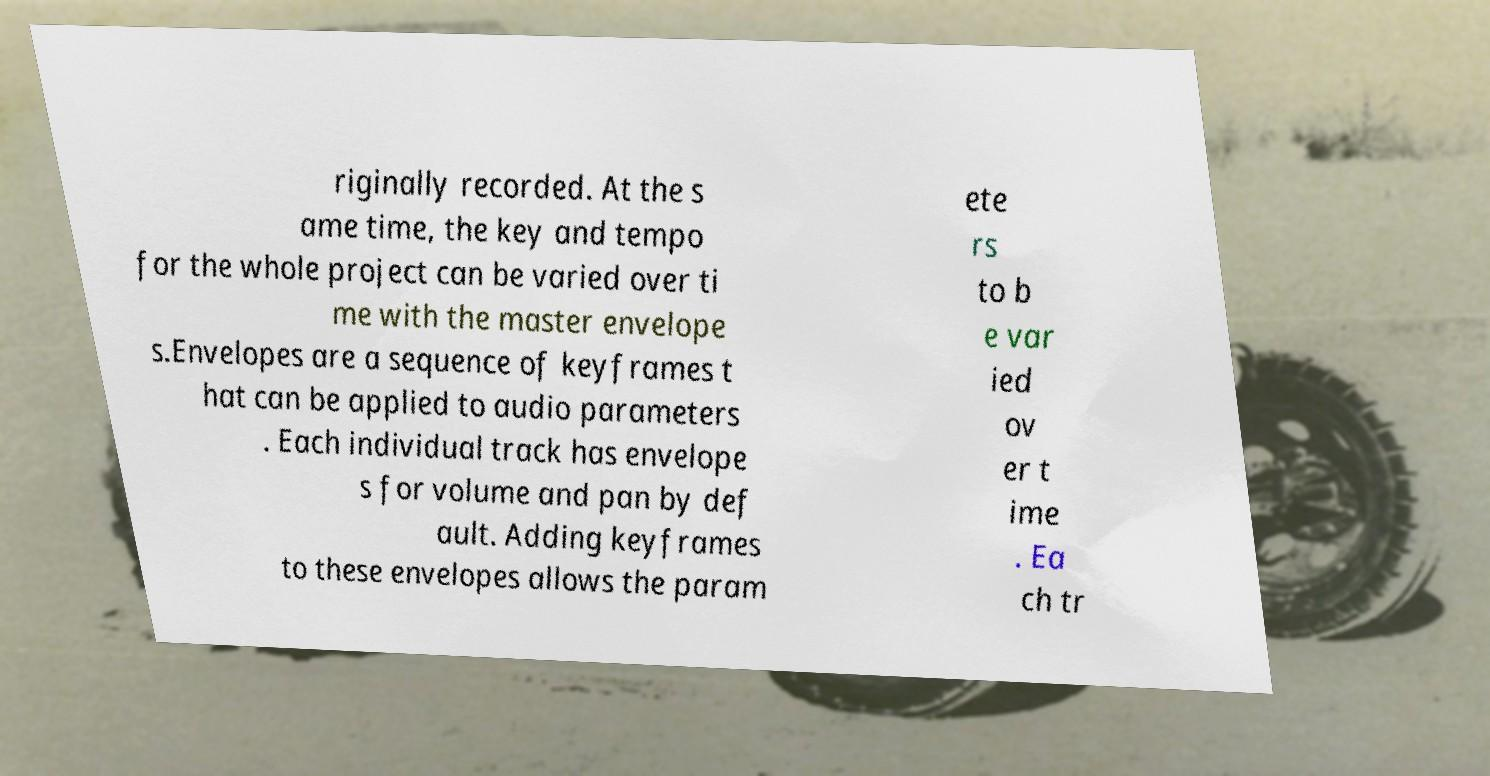Can you accurately transcribe the text from the provided image for me? riginally recorded. At the s ame time, the key and tempo for the whole project can be varied over ti me with the master envelope s.Envelopes are a sequence of keyframes t hat can be applied to audio parameters . Each individual track has envelope s for volume and pan by def ault. Adding keyframes to these envelopes allows the param ete rs to b e var ied ov er t ime . Ea ch tr 